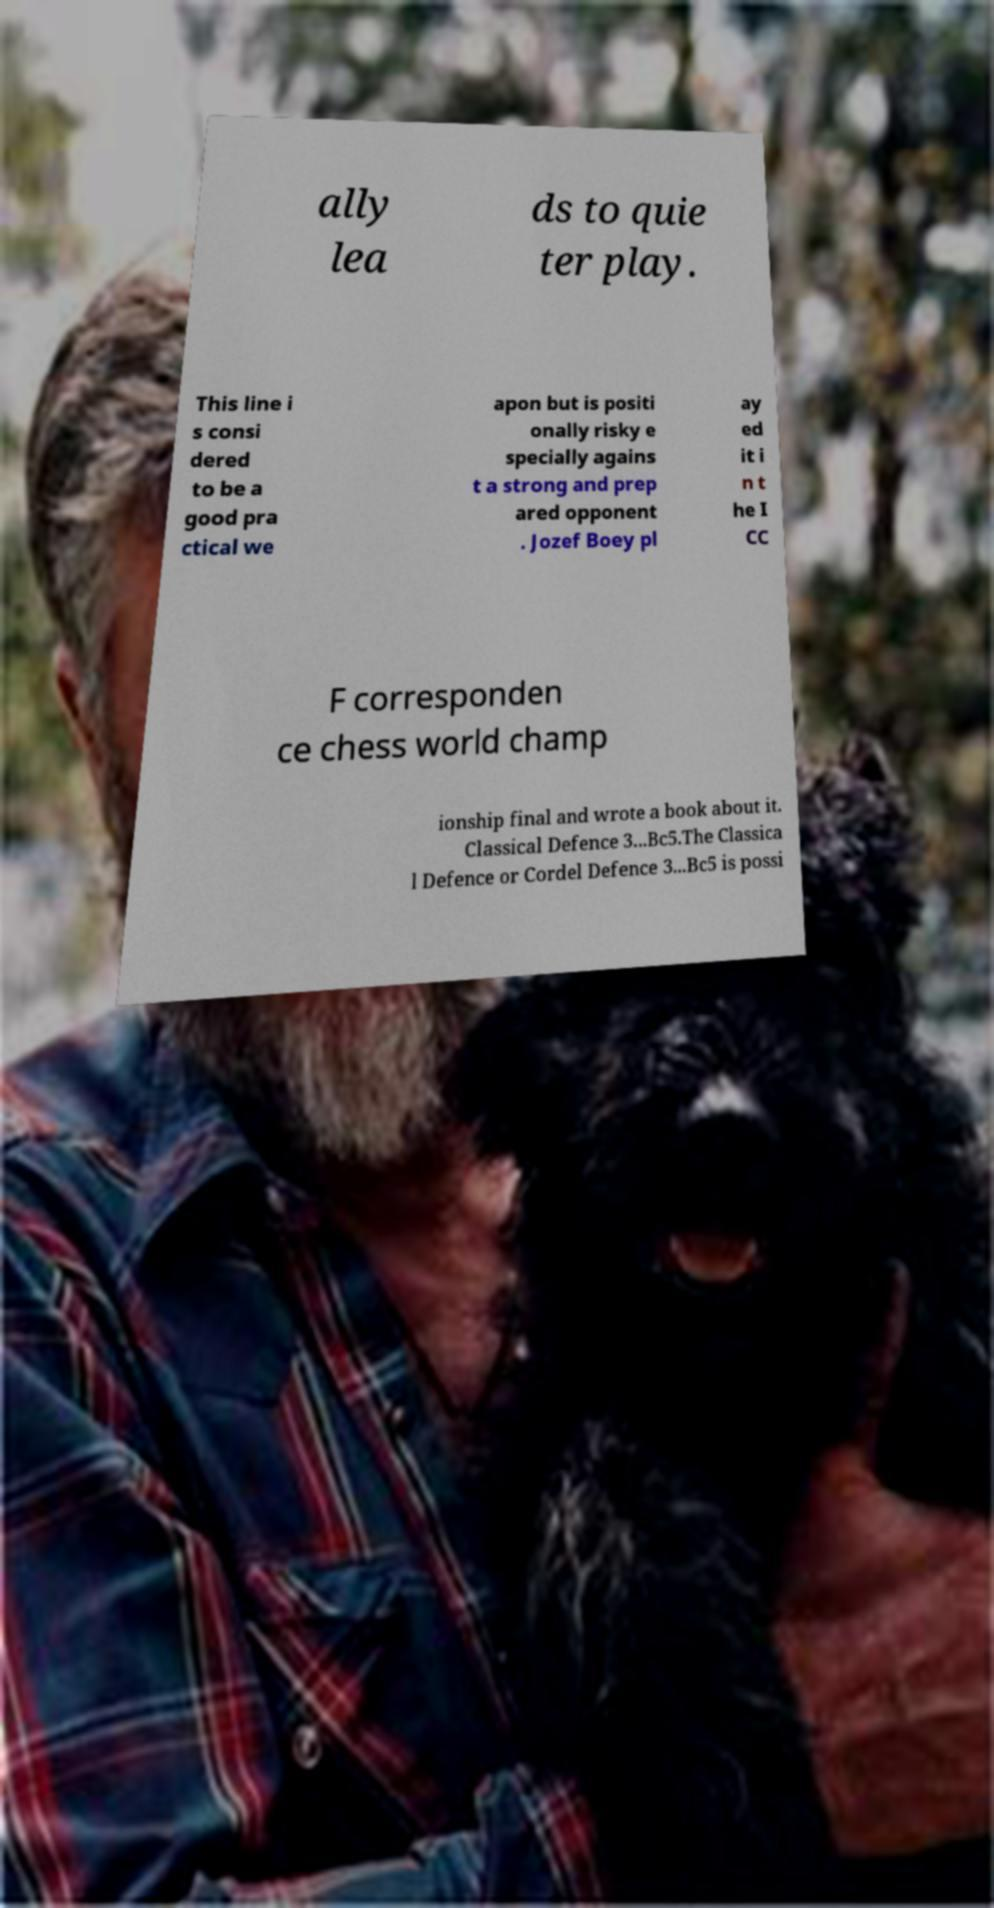Could you extract and type out the text from this image? ally lea ds to quie ter play. This line i s consi dered to be a good pra ctical we apon but is positi onally risky e specially agains t a strong and prep ared opponent . Jozef Boey pl ay ed it i n t he I CC F corresponden ce chess world champ ionship final and wrote a book about it. Classical Defence 3...Bc5.The Classica l Defence or Cordel Defence 3...Bc5 is possi 